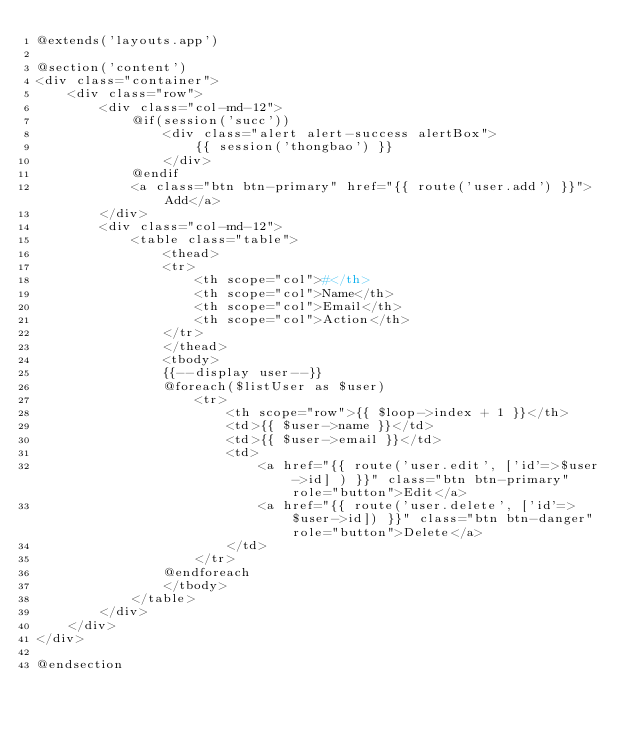<code> <loc_0><loc_0><loc_500><loc_500><_PHP_>@extends('layouts.app')

@section('content')
<div class="container">
    <div class="row">
        <div class="col-md-12">
            @if(session('succ'))
                <div class="alert alert-success alertBox">
                    {{ session('thongbao') }}
                </div>
            @endif
            <a class="btn btn-primary" href="{{ route('user.add') }}">Add</a>
        </div>
        <div class="col-md-12">
            <table class="table">
                <thead>
                <tr>
                    <th scope="col">#</th>
                    <th scope="col">Name</th>
                    <th scope="col">Email</th>
                    <th scope="col">Action</th>
                </tr>
                </thead>
                <tbody>
                {{--display user--}}
                @foreach($listUser as $user)
                    <tr>
                        <th scope="row">{{ $loop->index + 1 }}</th>
                        <td>{{ $user->name }}</td>
                        <td>{{ $user->email }}</td>
                        <td>
                            <a href="{{ route('user.edit', ['id'=>$user->id] ) }}" class="btn btn-primary" role="button">Edit</a>
                            <a href="{{ route('user.delete', ['id'=>$user->id]) }}" class="btn btn-danger" role="button">Delete</a>
                        </td>
                    </tr>
                @endforeach
                </tbody>
            </table>
        </div>
    </div>
</div>

@endsection</code> 